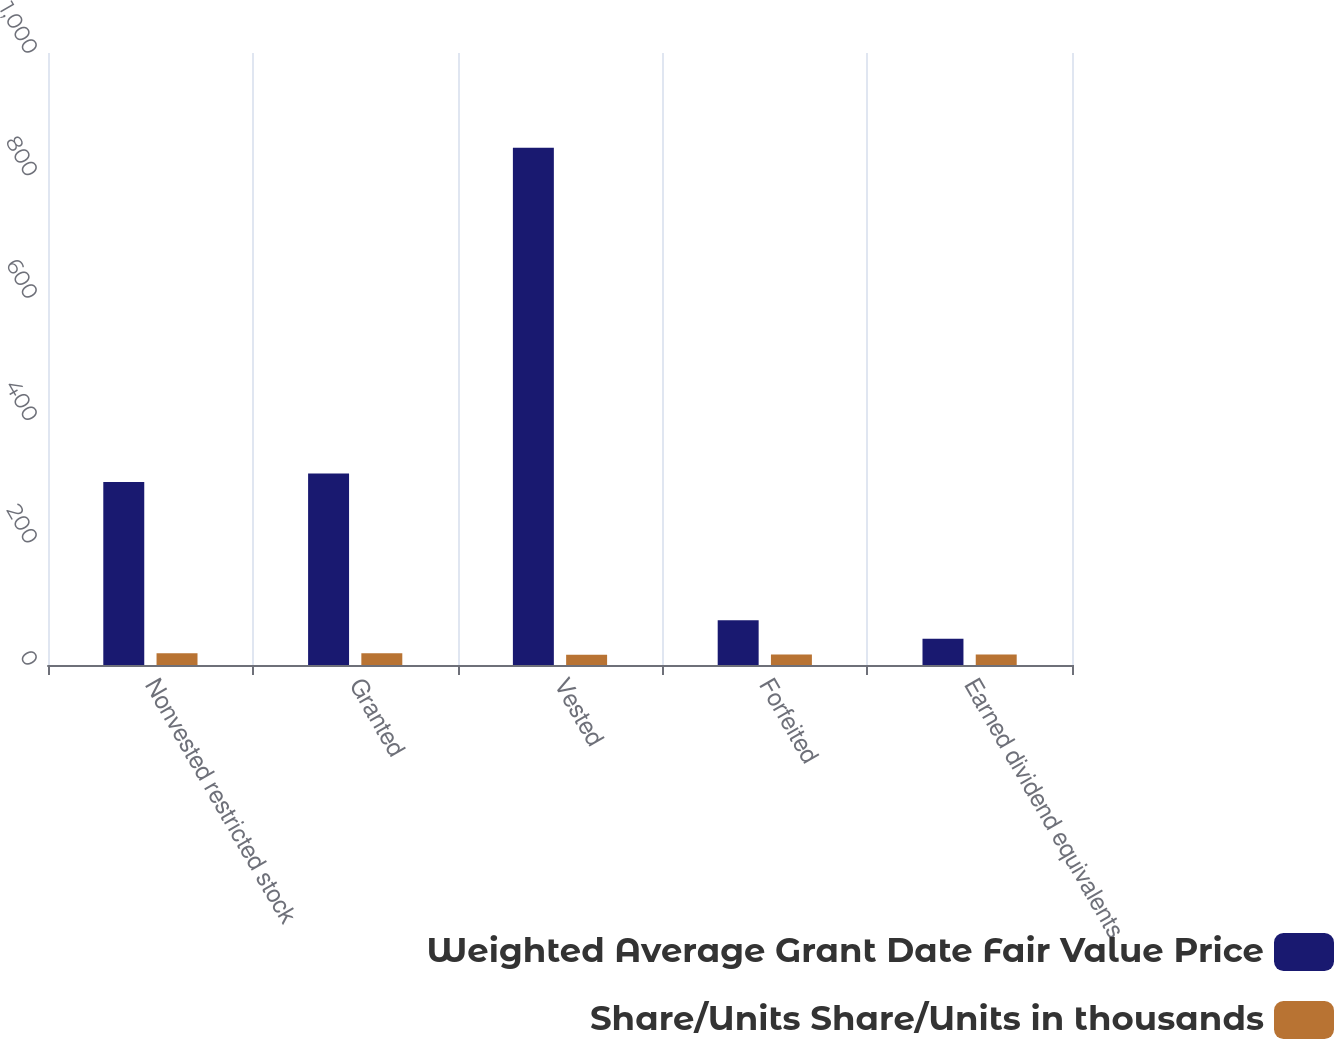<chart> <loc_0><loc_0><loc_500><loc_500><stacked_bar_chart><ecel><fcel>Nonvested restricted stock<fcel>Granted<fcel>Vested<fcel>Forfeited<fcel>Earned dividend equivalents<nl><fcel>Weighted Average Grant Date Fair Value Price<fcel>299<fcel>313<fcel>845<fcel>73<fcel>43<nl><fcel>Share/Units Share/Units in thousands<fcel>19.08<fcel>19.08<fcel>16.8<fcel>17.06<fcel>17.26<nl></chart> 